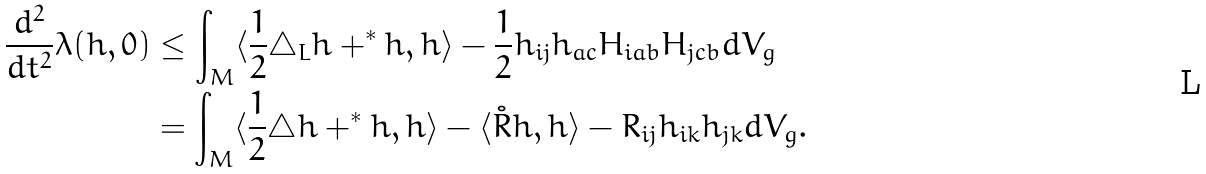Convert formula to latex. <formula><loc_0><loc_0><loc_500><loc_500>\frac { d ^ { 2 } } { d t ^ { 2 } } \lambda ( h , 0 ) & \leq \int _ { M } \langle \frac { 1 } { 2 } \triangle _ { L } h + ^ { * } h , h \rangle - \frac { 1 } { 2 } h _ { i j } h _ { a c } H _ { i a b } H _ { j c b } d V _ { g } \\ & = \int _ { M } \langle \frac { 1 } { 2 } \triangle h + ^ { * } h , h \rangle - \langle \mathring { R } h , h \rangle - R _ { i j } h _ { i k } h _ { j k } d V _ { g } .</formula> 